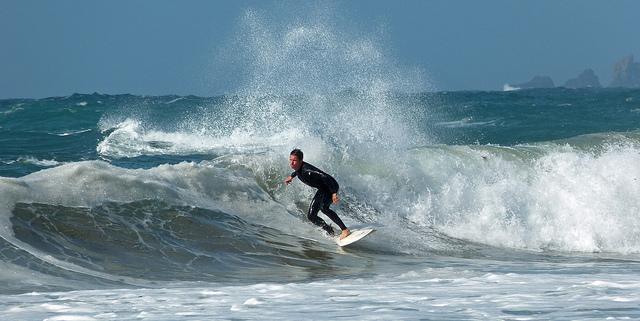What is the man standing on?
Short answer required. Surfboard. Does this activity require waves?
Concise answer only. Yes. What color is the board?
Keep it brief. White. 